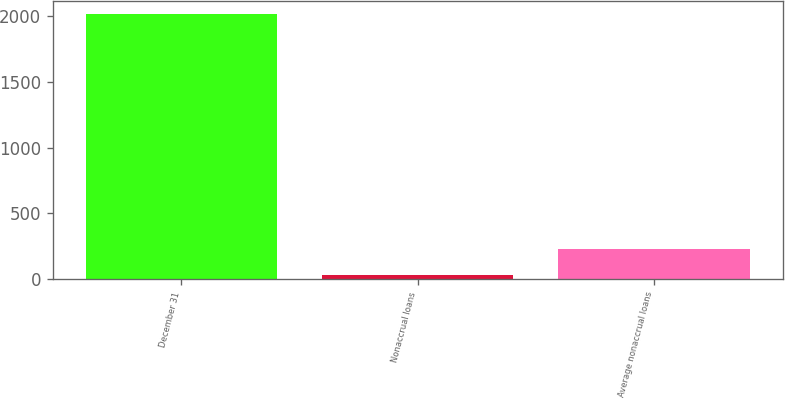Convert chart to OTSL. <chart><loc_0><loc_0><loc_500><loc_500><bar_chart><fcel>December 31<fcel>Nonaccrual loans<fcel>Average nonaccrual loans<nl><fcel>2014<fcel>35<fcel>232.9<nl></chart> 